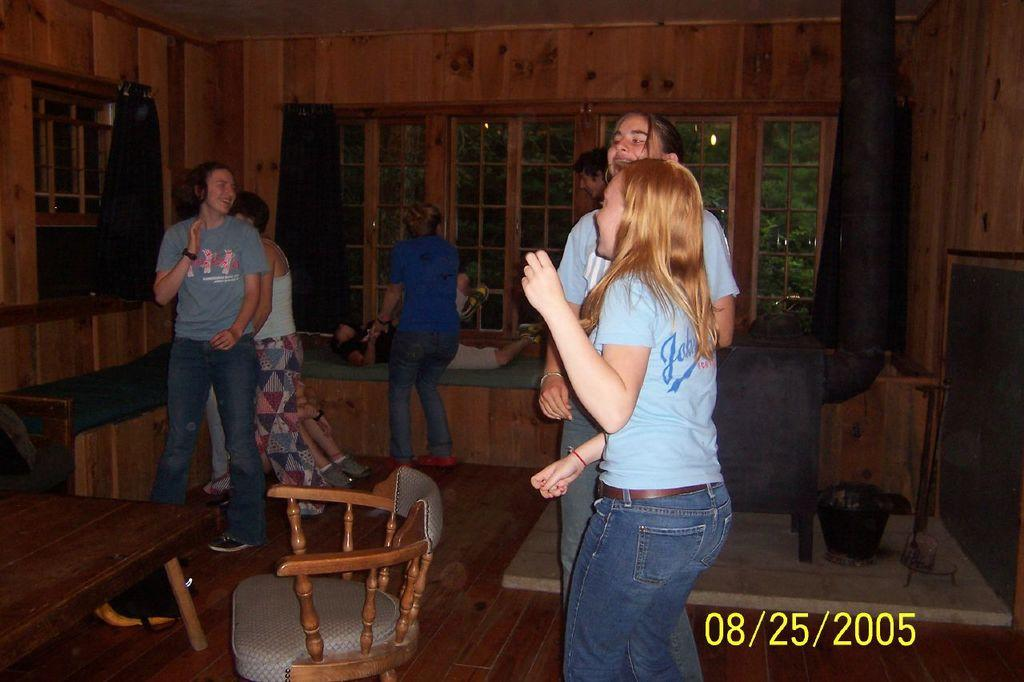How many people are in the image? There is a group of guys in the image. What are the guys doing in the image? The guys are enjoying themselves. What furniture is present in the image? There is a table and a chair in the image. What can be seen in the background of the image? There is a window in the background of the image, and trees are visible through the window. Is there any window treatment present in the image? Yes, there is a window curtain associated with the window. What type of scissors are the fairies using to cut the ink in the image? There are no fairies or ink present in the image, so it is not possible to answer that question. 